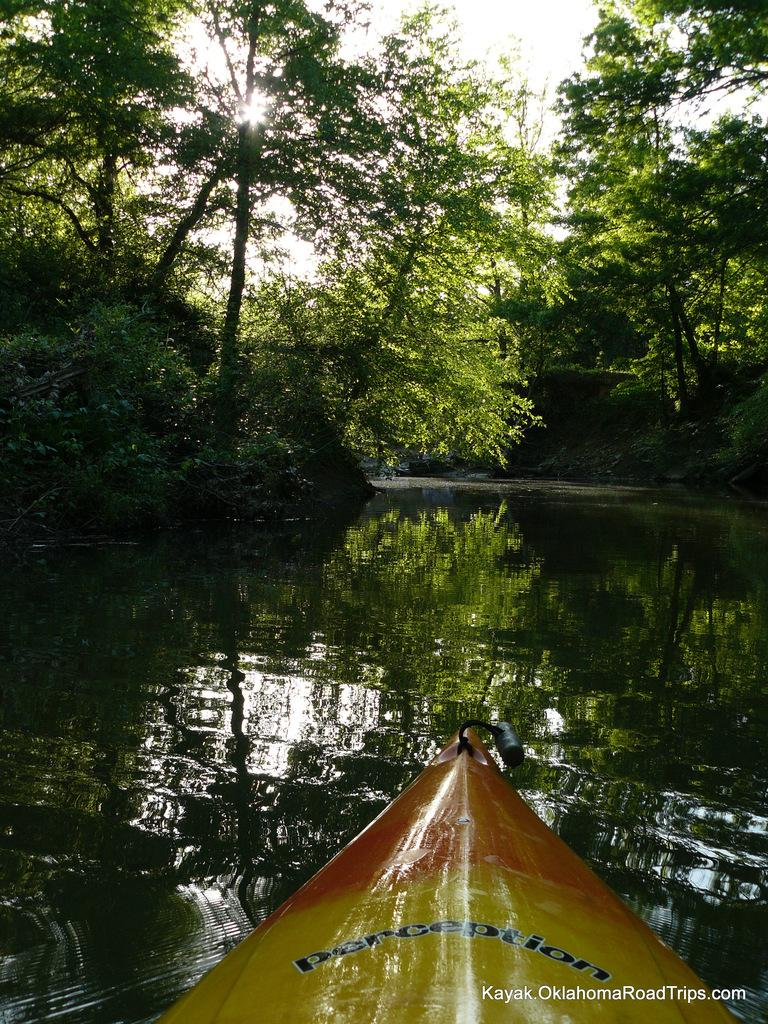What is the main subject in the foreground of the image? There is a boat in the foreground of the image. Where is the boat located? The boat is in the water. What can be seen in the background of the image? There is water, trees, and the sky visible in the background of the image. Can the sun be seen in the image? Yes, the sun is visible in the sky. What type of cough medicine is stored in the cellar in the image? There is no mention of a cellar or cough medicine in the image; it features a boat in the water with a background of trees, water, and the sky. 